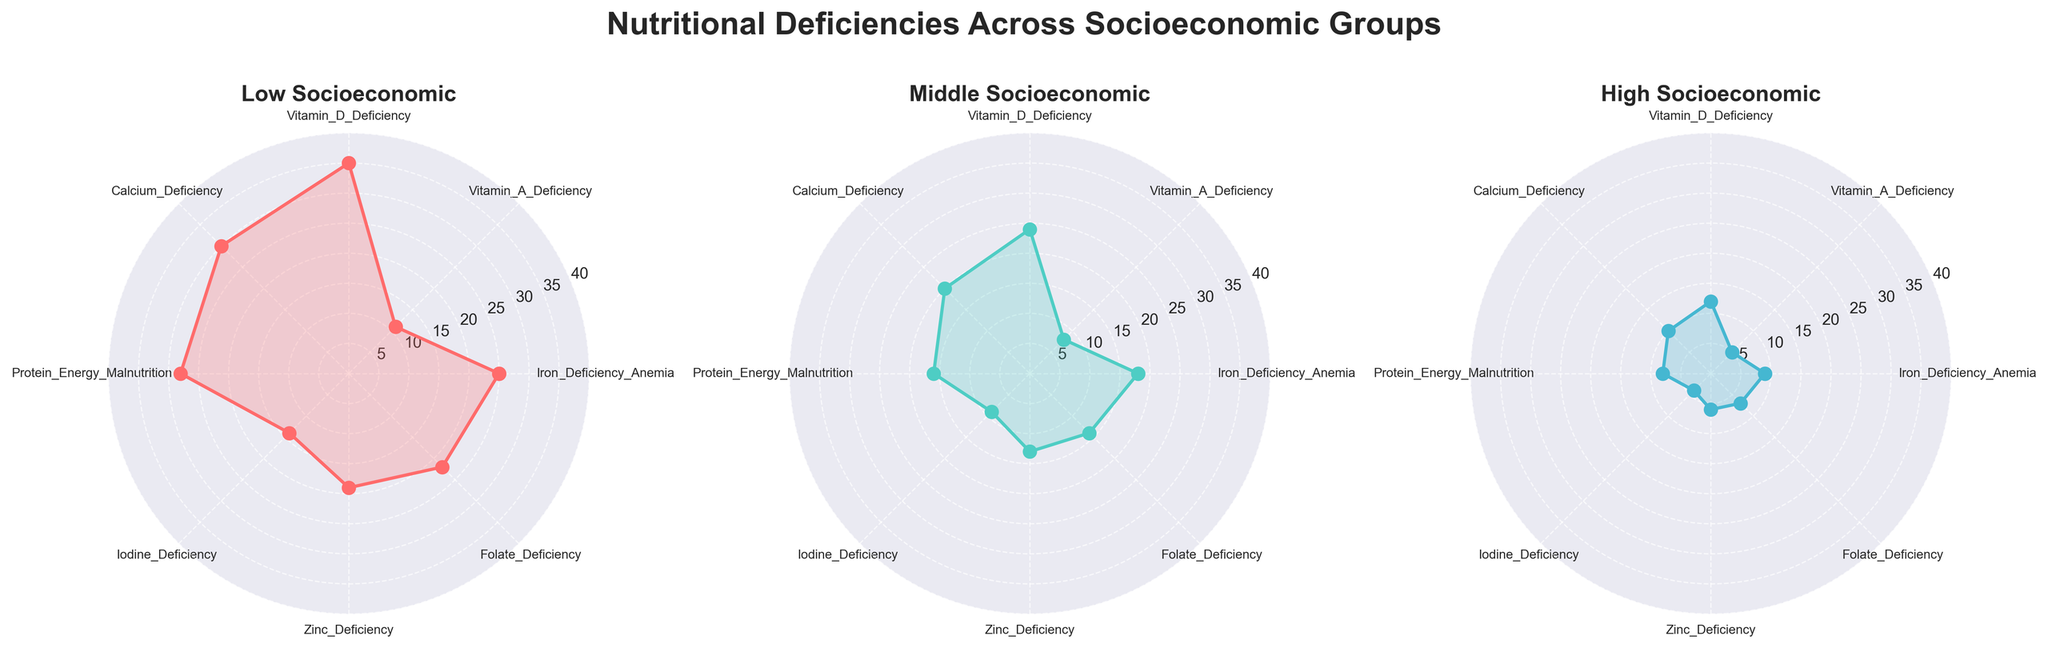Which socioeconomic group has the highest rate of Calcium Deficiency? In the plot, the Calcium Deficiency rates can be compared by observing the values on the respective axes of each radar chart. The Low Socioeconomic group has a Calcium Deficiency rate of 30%, Middle Socioeconomic group has a rate of 20%, and High Socioeconomic group has a rate of 10%. Thus, the Low Socioeconomic group has the highest rate.
Answer: Low Socioeconomic What are the ranges of values represented in the radar charts? From observing the radar charts, it is clear that the radial axis ranges from 0 to 40 percent.
Answer: 0 to 40% Which nutritional deficiency shows the largest difference between Low and Middle Socioeconomic groups? To answer this, compare the differences between Low and Middle Socioeconomic groups for each deficiency. The biggest difference is in Vitamin D Deficiency, where Low Socioeconomic is at 35% and Middle Socioeconomic is at 24%. The difference is 11%.
Answer: Vitamin D Deficiency Which group has the lowest overall deficiency rates? By visually inspecting the radar charts for overall deficiency rates across all categories, the High Socioeconomic group tends to have the lowest values across all deficiencies.
Answer: High Socioeconomic How does Zinc Deficiency vary across the three socioeconomic groups? Iron Deficiency rates in the radar charts show that Low Socioeconomic has 19%, Middle Socioeconomic has 13%, and High Socioeconomic has 6%.
Answer: 19%, 13%, 6% What is the difference in Iron Deficiency Anemia rates between the Low and High Socioeconomic groups? The Iron Deficiency Anemia rate in the Low Socioeconomic group is 25% and in the High Socioeconomic group, it is 9%. The difference between these rates is 25% - 9% = 16%.
Answer: 16% Which deficiency shows the smallest difference between Middle and High Socioeconomic groups? Observing the differences between Middle and High Socioeconomic values in the radar charts, Vitamin A Deficiency shows the smallest difference with Middle Socioeconomic at 8% and High Socioeconomic at 5%, resulting in a difference of 3%.
Answer: Vitamin A Deficiency What's the average Iron Deficiency Anemia rate across all three socioeconomic groups? Iron Deficiency Anemia rates are 25% for Low, 18% for Middle, and 9% for High Socioeconomic groups. The average is calculated as (25 + 18 + 9) / 3 = 17.33%.
Answer: 17.33% Are there any deficiencies with a consistent difference in rates across all socioeconomic groups? By comparing the radar chart plots, Vitamin A Deficiency has a consistent gap: 6% difference between Low and Middle, and 3% between Middle and High Socioeconomic groups, showing a gradually consistent decrease.
Answer: Vitamin A Deficiency 